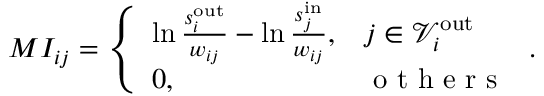Convert formula to latex. <formula><loc_0><loc_0><loc_500><loc_500>M I _ { i j } = \left \{ \begin{array} { l l } { \ln \frac { s _ { i } ^ { o u t } } { w _ { i j } } - \ln \frac { s _ { j } ^ { i n } } { w _ { i j } } , } & { j \in \ m a t h s c r { V } _ { i } ^ { o u t } } \\ { 0 , } & { o t h e r s } \end{array} .</formula> 